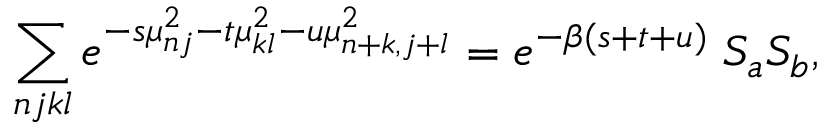Convert formula to latex. <formula><loc_0><loc_0><loc_500><loc_500>\sum _ { n j k l } e ^ { - s \mu _ { n j } ^ { 2 } - t \mu _ { k l } ^ { 2 } - u \mu _ { n + k , j + l } ^ { 2 } } = e ^ { - \beta ( s + t + u ) } \, S _ { a } S _ { b } ,</formula> 